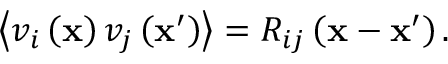<formula> <loc_0><loc_0><loc_500><loc_500>\left \langle v _ { i } \left ( x \right ) v _ { j } \left ( x ^ { \prime } \right ) \right \rangle = R _ { i j } \left ( x - x ^ { \prime } \right ) .</formula> 